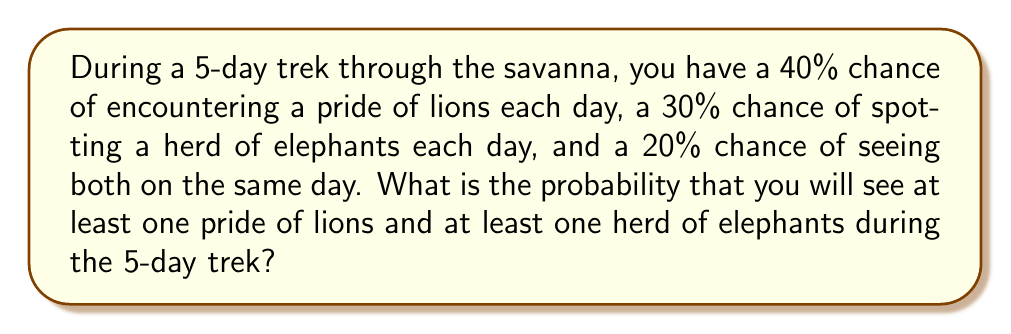Give your solution to this math problem. Let's approach this step-by-step:

1) First, let's calculate the probability of not seeing lions on a single day:
   $P(\text{no lions}) = 1 - 0.4 = 0.6$

2) The probability of not seeing lions for all 5 days:
   $P(\text{no lions for 5 days}) = 0.6^5 = 0.07776$

3) Therefore, the probability of seeing lions at least once in 5 days:
   $P(\text{lions at least once}) = 1 - 0.07776 = 0.92224$

4) Similarly for elephants:
   $P(\text{no elephants}) = 1 - 0.3 = 0.7$
   $P(\text{no elephants for 5 days}) = 0.7^5 = 0.16807$
   $P(\text{elephants at least once}) = 1 - 0.16807 = 0.83193$

5) Now, we need to find the probability of seeing both lions and elephants. This is not simply the product of the two probabilities we calculated, because the events are not independent (we're told there's a 20% chance of seeing both on the same day).

6) Instead, let's calculate the probability of not seeing both:
   - Probability of not seeing lions OR not seeing elephants on a single day:
     $P(\text{not both}) = 1 - 0.2 = 0.8$

7) Probability of not seeing both for all 5 days:
   $P(\text{not both for 5 days}) = 0.8^5 = 0.32768$

8) Therefore, the probability of seeing both at least once in 5 days:
   $P(\text{both at least once}) = 1 - 0.32768 = 0.67232$

This is our final answer.
Answer: 0.67232 